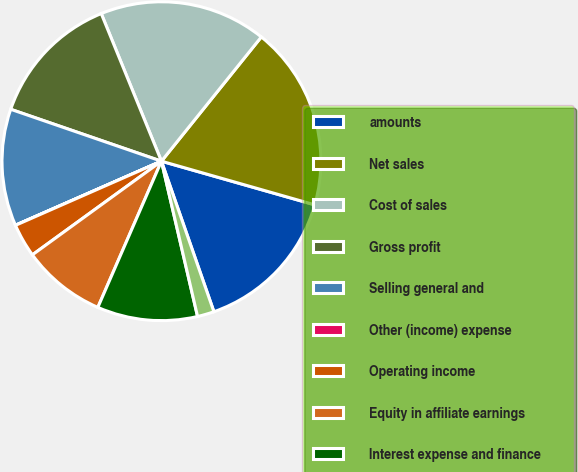<chart> <loc_0><loc_0><loc_500><loc_500><pie_chart><fcel>amounts<fcel>Net sales<fcel>Cost of sales<fcel>Gross profit<fcel>Selling general and<fcel>Other (income) expense<fcel>Operating income<fcel>Equity in affiliate earnings<fcel>Interest expense and finance<fcel>Income before income taxes and<nl><fcel>15.25%<fcel>18.64%<fcel>16.94%<fcel>13.56%<fcel>11.86%<fcel>0.01%<fcel>3.4%<fcel>8.48%<fcel>10.17%<fcel>1.7%<nl></chart> 